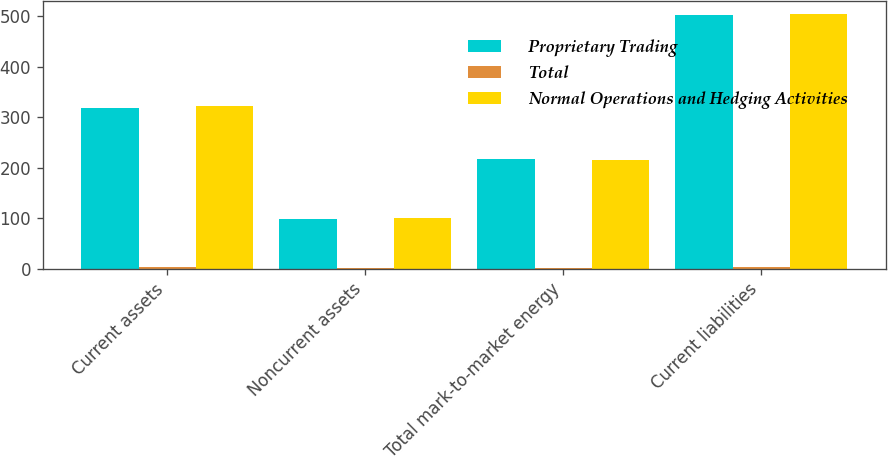Convert chart to OTSL. <chart><loc_0><loc_0><loc_500><loc_500><stacked_bar_chart><ecel><fcel>Current assets<fcel>Noncurrent assets<fcel>Total mark-to-market energy<fcel>Current liabilities<nl><fcel>Proprietary Trading<fcel>319<fcel>99<fcel>217<fcel>502<nl><fcel>Total<fcel>3<fcel>1<fcel>1<fcel>3<nl><fcel>Normal Operations and Hedging Activities<fcel>322<fcel>100<fcel>216<fcel>505<nl></chart> 